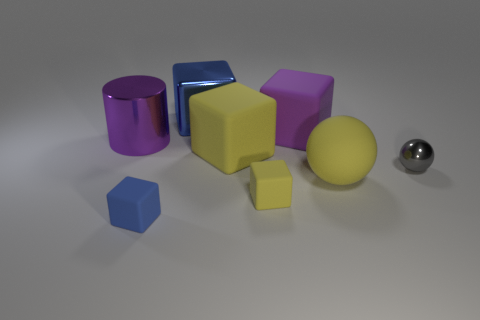There is a yellow block that is in front of the large yellow thing that is on the left side of the matte sphere; what number of yellow spheres are to the left of it? Actually, there are no yellow spheres to the left of the matte sphere; in the image, you can see that there are two yellow cubes and one purple cube to the left of the matte sphere, with a purple cylinder and a blue rectangular prism further to the left. 